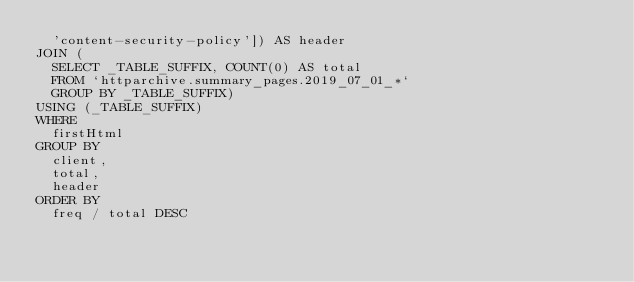<code> <loc_0><loc_0><loc_500><loc_500><_SQL_>  'content-security-policy']) AS header
JOIN (
  SELECT _TABLE_SUFFIX, COUNT(0) AS total
  FROM `httparchive.summary_pages.2019_07_01_*`
  GROUP BY _TABLE_SUFFIX)
USING (_TABLE_SUFFIX)
WHERE
  firstHtml
GROUP BY
  client,
  total,
  header
ORDER BY
  freq / total DESC
</code> 